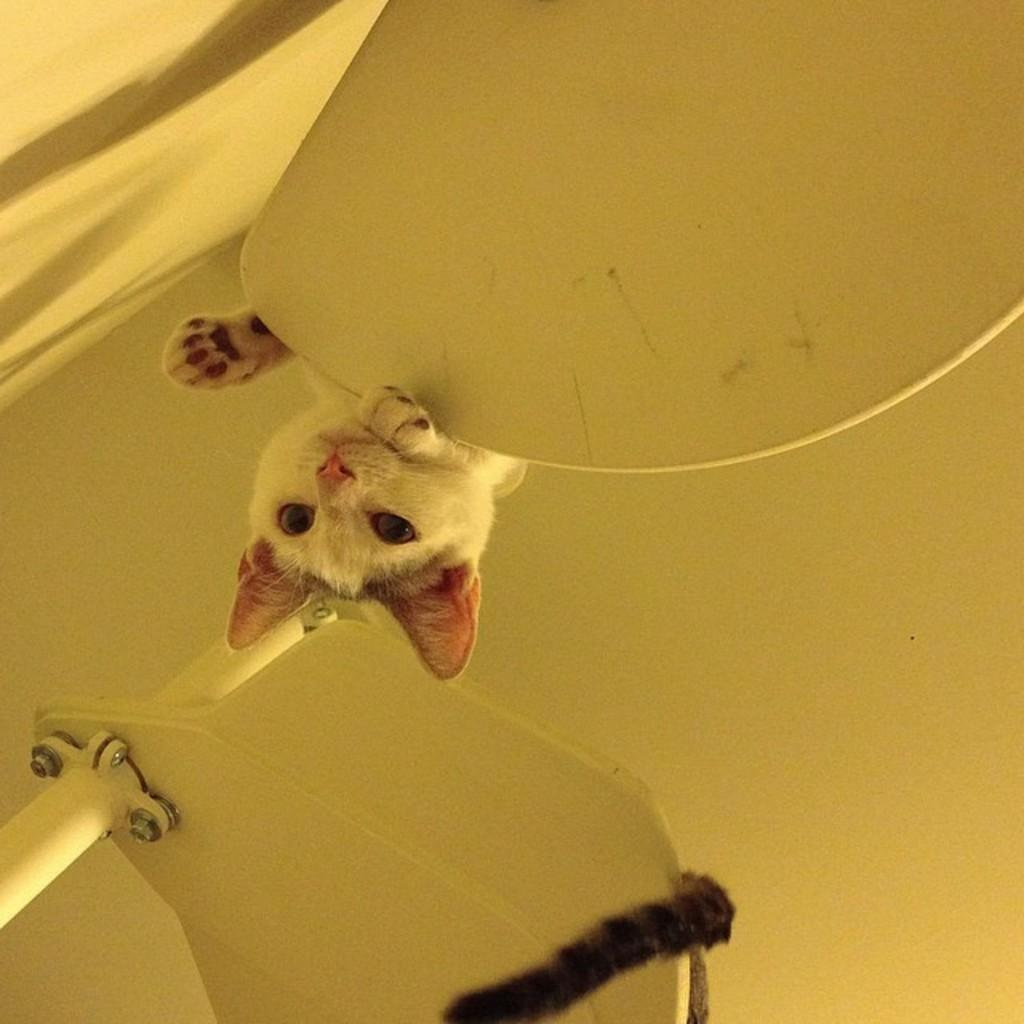What is the main subject of the image? There is a cat in the center of the image. What part of the cat can be seen in the image? The cat's tail is visible in the image. What type of structure is present in the image? There is an iron frame in the image. Can you describe any other objects in the image? There are some objects in the image. What is the color of the object in the background? There is a white object in the background, possibly a ceiling. Is there any indication of a wall in the image? There might be a wall on the left side of the image. How many ducks are swimming in the image? There are no ducks present in the image, and therefore no swimming activity can be observed. What advice would the cat's grandfather give in the image? There is no grandfather present in the image, so it is not possible to determine any advice he might give. 